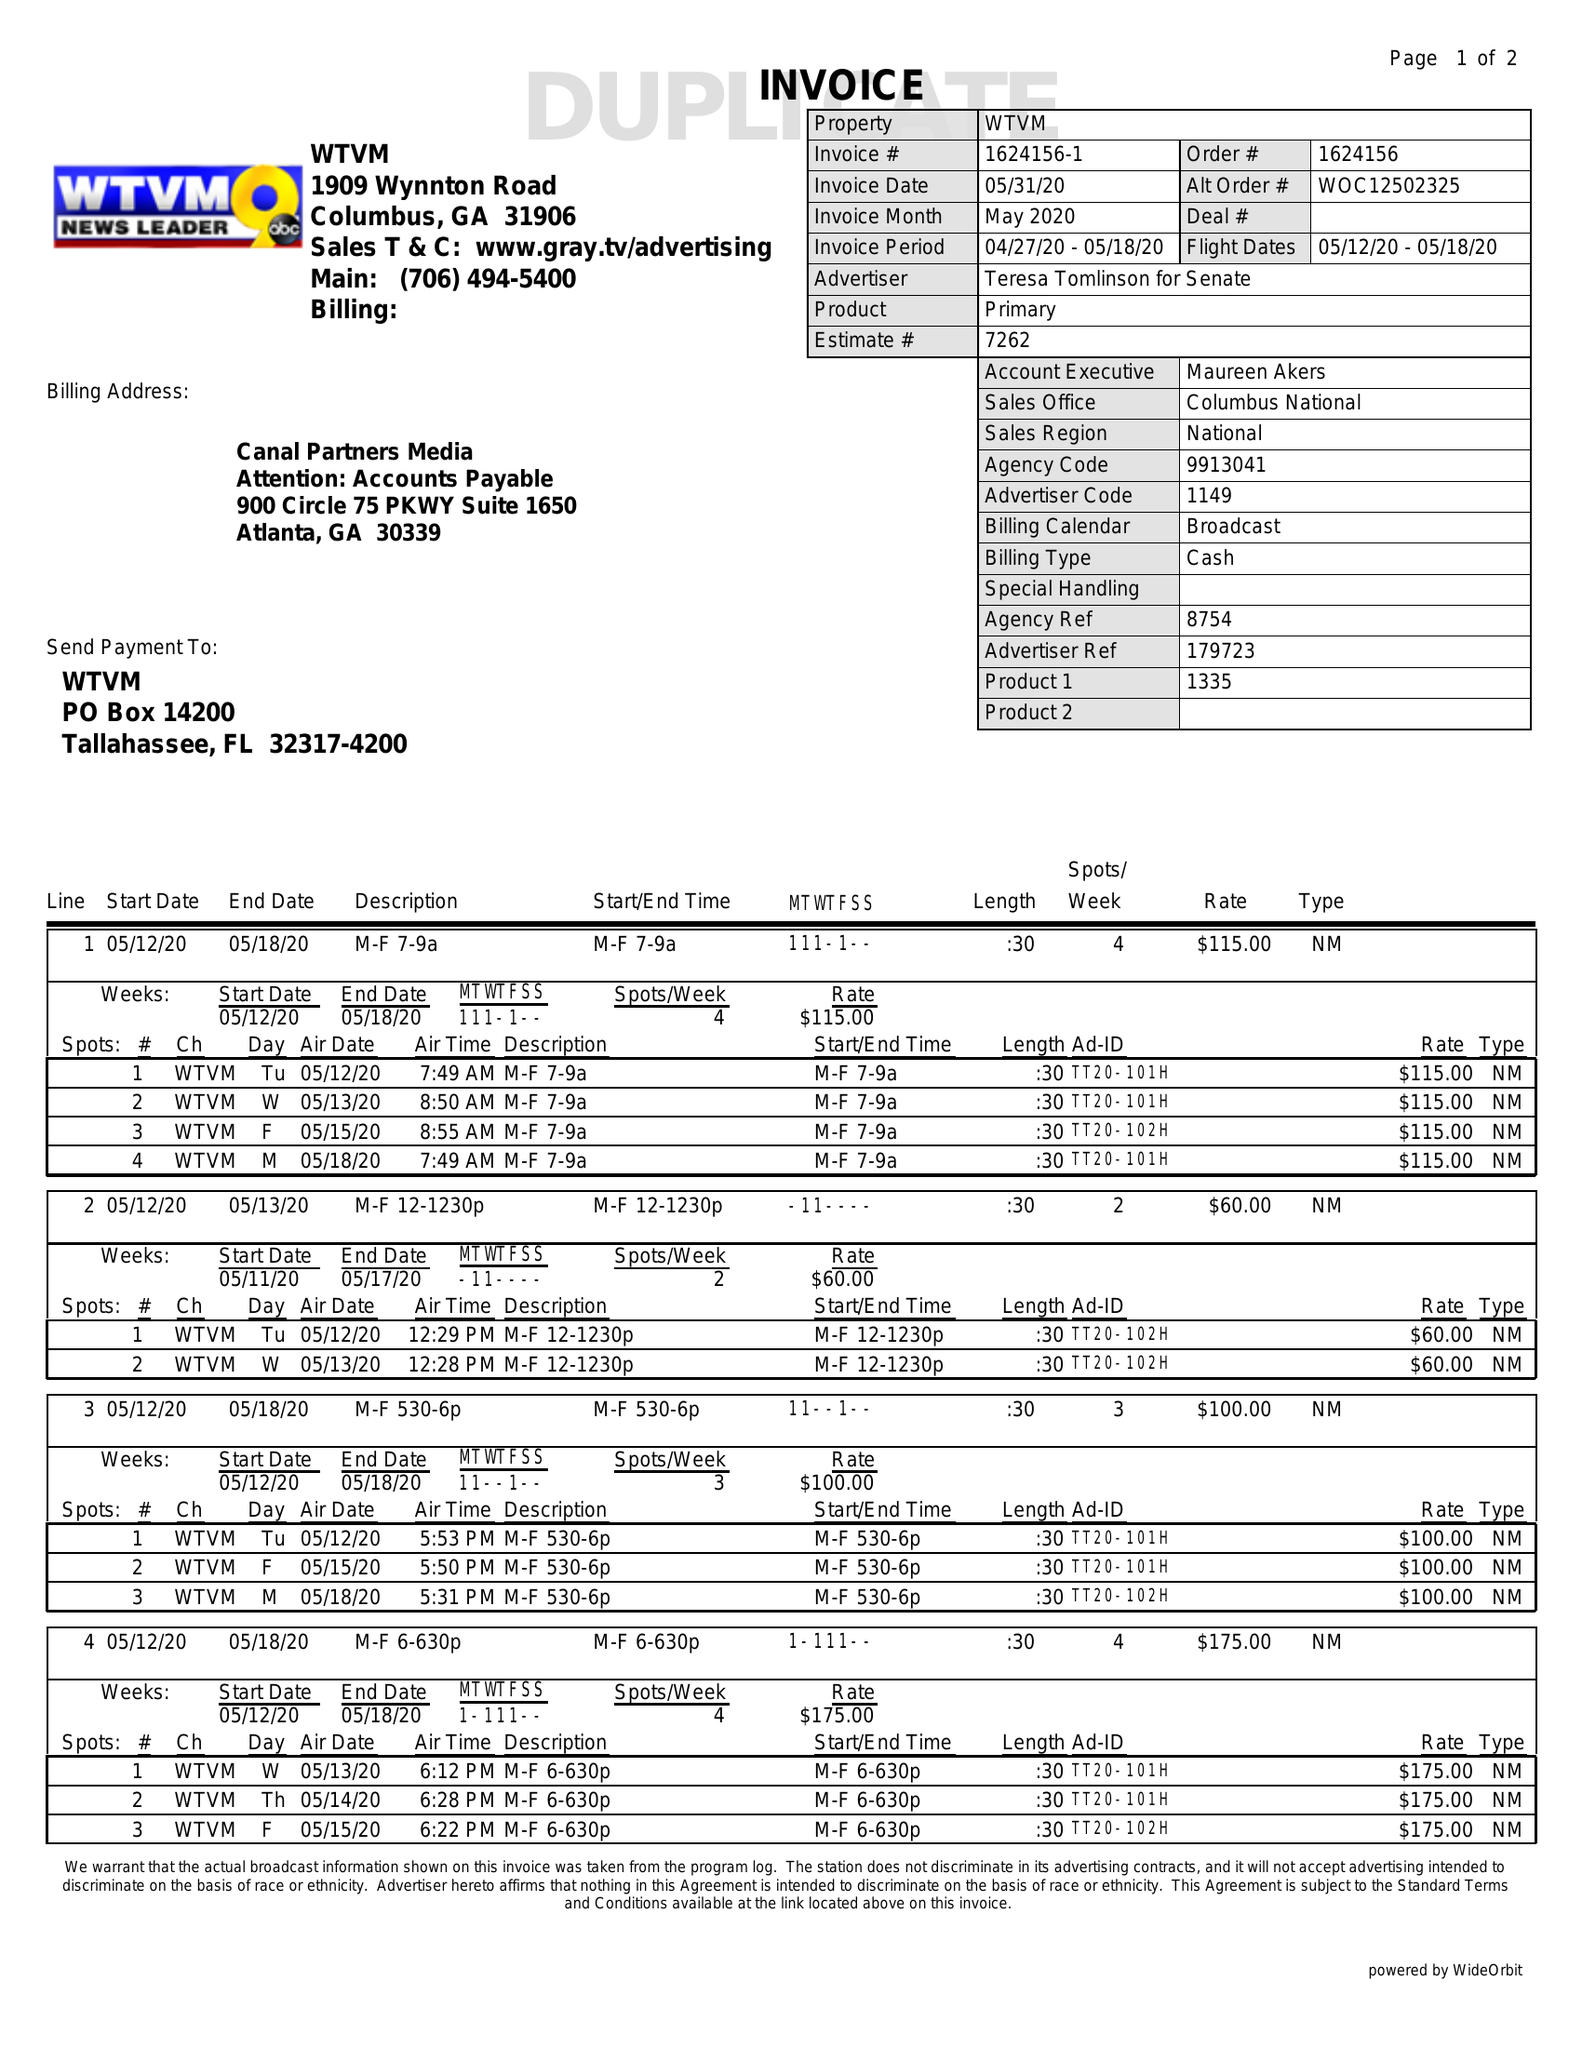What is the value for the flight_to?
Answer the question using a single word or phrase. 05/18/20 